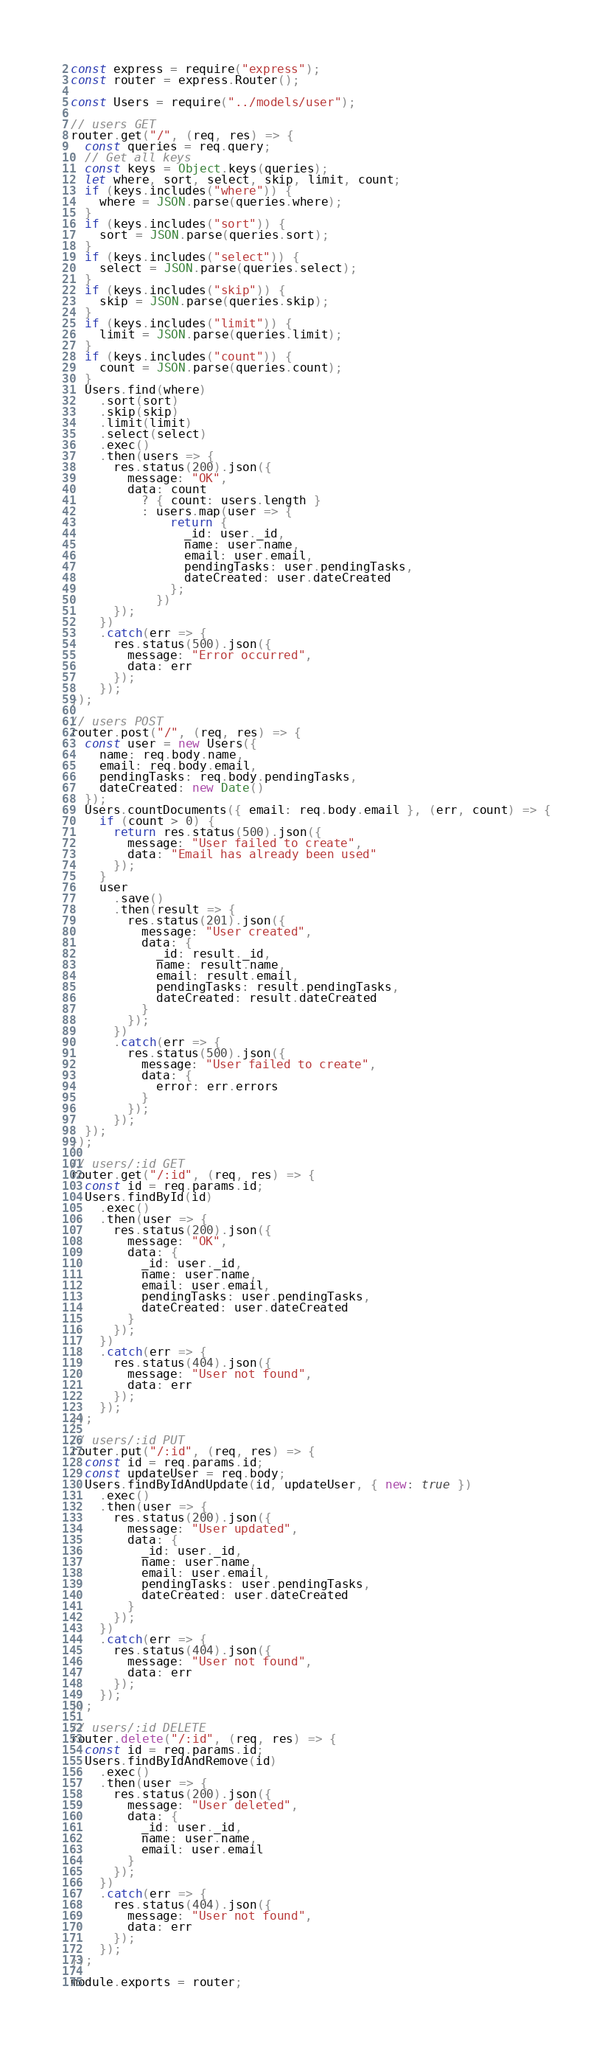<code> <loc_0><loc_0><loc_500><loc_500><_JavaScript_>const express = require("express");
const router = express.Router();

const Users = require("../models/user");

// users GET
router.get("/", (req, res) => {
  const queries = req.query;
  // Get all keys
  const keys = Object.keys(queries);
  let where, sort, select, skip, limit, count;
  if (keys.includes("where")) {
    where = JSON.parse(queries.where);
  }
  if (keys.includes("sort")) {
    sort = JSON.parse(queries.sort);
  }
  if (keys.includes("select")) {
    select = JSON.parse(queries.select);
  }
  if (keys.includes("skip")) {
    skip = JSON.parse(queries.skip);
  }
  if (keys.includes("limit")) {
    limit = JSON.parse(queries.limit);
  }
  if (keys.includes("count")) {
    count = JSON.parse(queries.count);
  }
  Users.find(where)
    .sort(sort)
    .skip(skip)
    .limit(limit)
    .select(select)
    .exec()
    .then(users => {
      res.status(200).json({
        message: "OK",
        data: count
          ? { count: users.length }
          : users.map(user => {
              return {
                _id: user._id,
                name: user.name,
                email: user.email,
                pendingTasks: user.pendingTasks,
                dateCreated: user.dateCreated
              };
            })
      });
    })
    .catch(err => {
      res.status(500).json({
        message: "Error occurred",
        data: err
      });
    });
});

// users POST
router.post("/", (req, res) => {
  const user = new Users({
    name: req.body.name,
    email: req.body.email,
    pendingTasks: req.body.pendingTasks,
    dateCreated: new Date()
  });
  Users.countDocuments({ email: req.body.email }, (err, count) => {
    if (count > 0) {
      return res.status(500).json({
        message: "User failed to create",
        data: "Email has already been used"
      });
    }
    user
      .save()
      .then(result => {
        res.status(201).json({
          message: "User created",
          data: {
            _id: result._id,
            name: result.name,
            email: result.email,
            pendingTasks: result.pendingTasks,
            dateCreated: result.dateCreated
          }
        });
      })
      .catch(err => {
        res.status(500).json({
          message: "User failed to create",
          data: {
            error: err.errors
          }
        });
      });
  });
});

// users/:id GET
router.get("/:id", (req, res) => {
  const id = req.params.id;
  Users.findById(id)
    .exec()
    .then(user => {
      res.status(200).json({
        message: "OK",
        data: {
          _id: user._id,
          name: user.name,
          email: user.email,
          pendingTasks: user.pendingTasks,
          dateCreated: user.dateCreated
        }
      });
    })
    .catch(err => {
      res.status(404).json({
        message: "User not found",
        data: err
      });
    });
});

// users/:id PUT
router.put("/:id", (req, res) => {
  const id = req.params.id;
  const updateUser = req.body;
  Users.findByIdAndUpdate(id, updateUser, { new: true })
    .exec()
    .then(user => {
      res.status(200).json({
        message: "User updated",
        data: {
          _id: user._id,
          name: user.name,
          email: user.email,
          pendingTasks: user.pendingTasks,
          dateCreated: user.dateCreated
        }
      });
    })
    .catch(err => {
      res.status(404).json({
        message: "User not found",
        data: err
      });
    });
});

// users/:id DELETE
router.delete("/:id", (req, res) => {
  const id = req.params.id;
  Users.findByIdAndRemove(id)
    .exec()
    .then(user => {
      res.status(200).json({
        message: "User deleted",
        data: {
          _id: user._id,
          name: user.name,
          email: user.email
        }
      });
    })
    .catch(err => {
      res.status(404).json({
        message: "User not found",
        data: err
      });
    });
});

module.exports = router;
</code> 